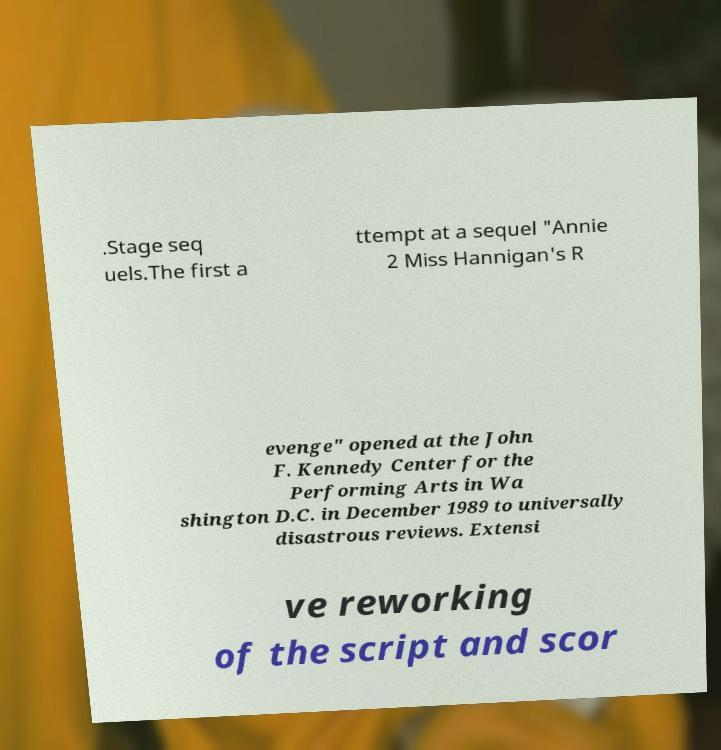I need the written content from this picture converted into text. Can you do that? .Stage seq uels.The first a ttempt at a sequel "Annie 2 Miss Hannigan's R evenge" opened at the John F. Kennedy Center for the Performing Arts in Wa shington D.C. in December 1989 to universally disastrous reviews. Extensi ve reworking of the script and scor 